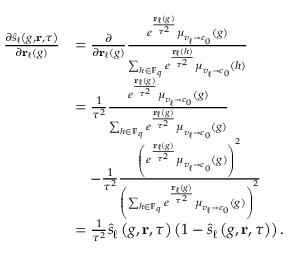<formula> <loc_0><loc_0><loc_500><loc_500>\begin{array} { r l } { \frac { \partial \hat { s } _ { \ell } \left ( g , { r } , \tau \right ) } { \partial { r } _ { \ell } ( g ) } } & { = \frac { \partial } { \partial { r } _ { \ell } ( g ) } \frac { e ^ { \frac { { r } _ { \ell } ( g ) } { \tau ^ { 2 } } } \mu _ { v _ { \ell } \to c _ { 0 } } ( g ) } { \sum _ { h \in \mathbb { F } _ { q } } e ^ { \frac { { r } _ { \ell } ( h ) } { \tau ^ { 2 } } } \mu _ { v _ { \ell } \to c _ { 0 } } ( h ) } } \\ & { = \frac { 1 } { \tau ^ { 2 } } \frac { e ^ { \frac { { r } _ { \ell } ( g ) } { \tau ^ { 2 } } } \mu _ { v _ { \ell } \to c _ { 0 } } ( g ) } { \sum _ { h \in \mathbb { F } _ { q } } e ^ { \frac { { r } _ { \ell } ( g ) } { \tau ^ { 2 } } } \mu _ { v _ { \ell } \to c _ { 0 } } ( g ) } } \\ & { \quad - \frac { 1 } { \tau ^ { 2 } } \frac { \left ( e ^ { \frac { { r } _ { \ell } ( g ) } { \tau ^ { 2 } } } \mu _ { v _ { \ell } \to c _ { 0 } } ( g ) \right ) ^ { 2 } } { \left ( \sum _ { h \in \mathbb { F } _ { q } } e ^ { \frac { { r } _ { \ell } ( g ) } { \tau ^ { 2 } } } \mu _ { v _ { \ell } \to c _ { 0 } } ( g ) \right ) ^ { 2 } } } \\ & { = \frac { 1 } { \tau ^ { 2 } } \hat { s } _ { \ell } \left ( g , { r } , \tau \right ) \left ( 1 - \hat { s } _ { \ell } \left ( g , { r } , \tau \right ) \right ) . } \end{array}</formula> 